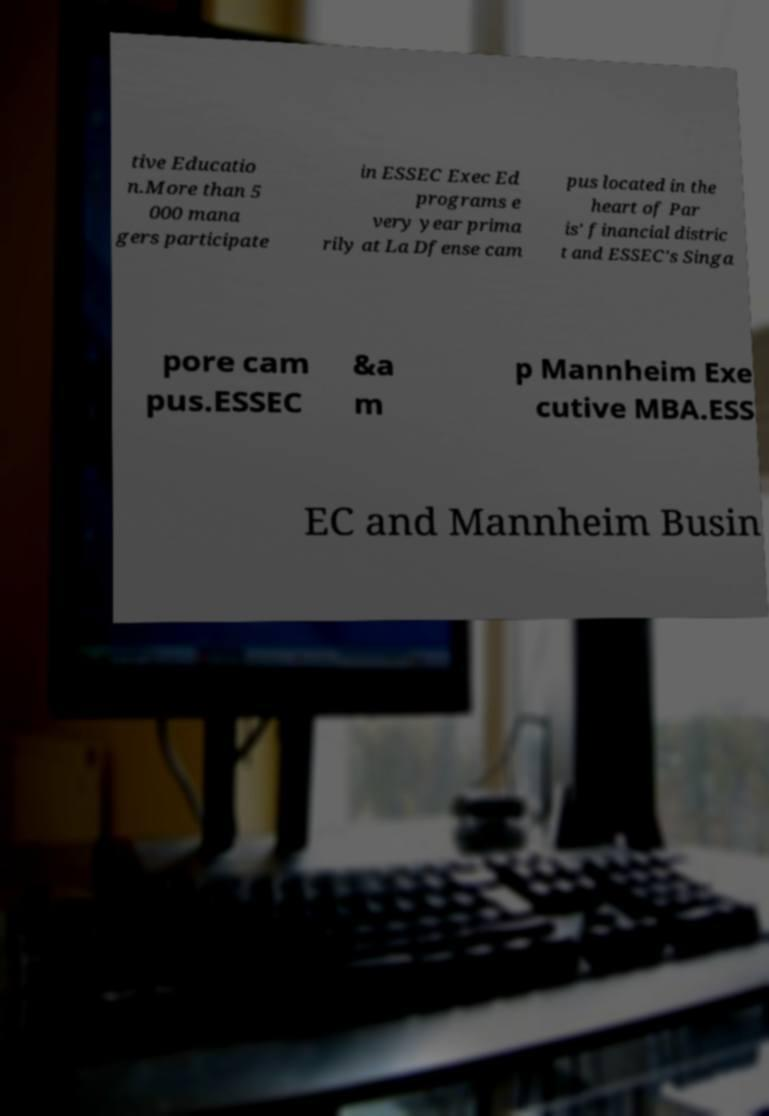Can you read and provide the text displayed in the image?This photo seems to have some interesting text. Can you extract and type it out for me? tive Educatio n.More than 5 000 mana gers participate in ESSEC Exec Ed programs e very year prima rily at La Dfense cam pus located in the heart of Par is’ financial distric t and ESSEC's Singa pore cam pus.ESSEC &a m p Mannheim Exe cutive MBA.ESS EC and Mannheim Busin 